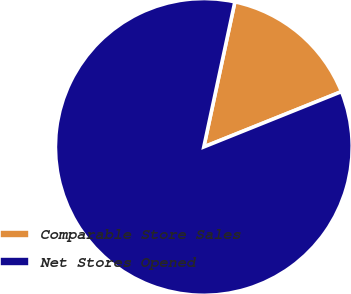<chart> <loc_0><loc_0><loc_500><loc_500><pie_chart><fcel>Comparable Store Sales<fcel>Net Stores Opened<nl><fcel>15.56%<fcel>84.44%<nl></chart> 